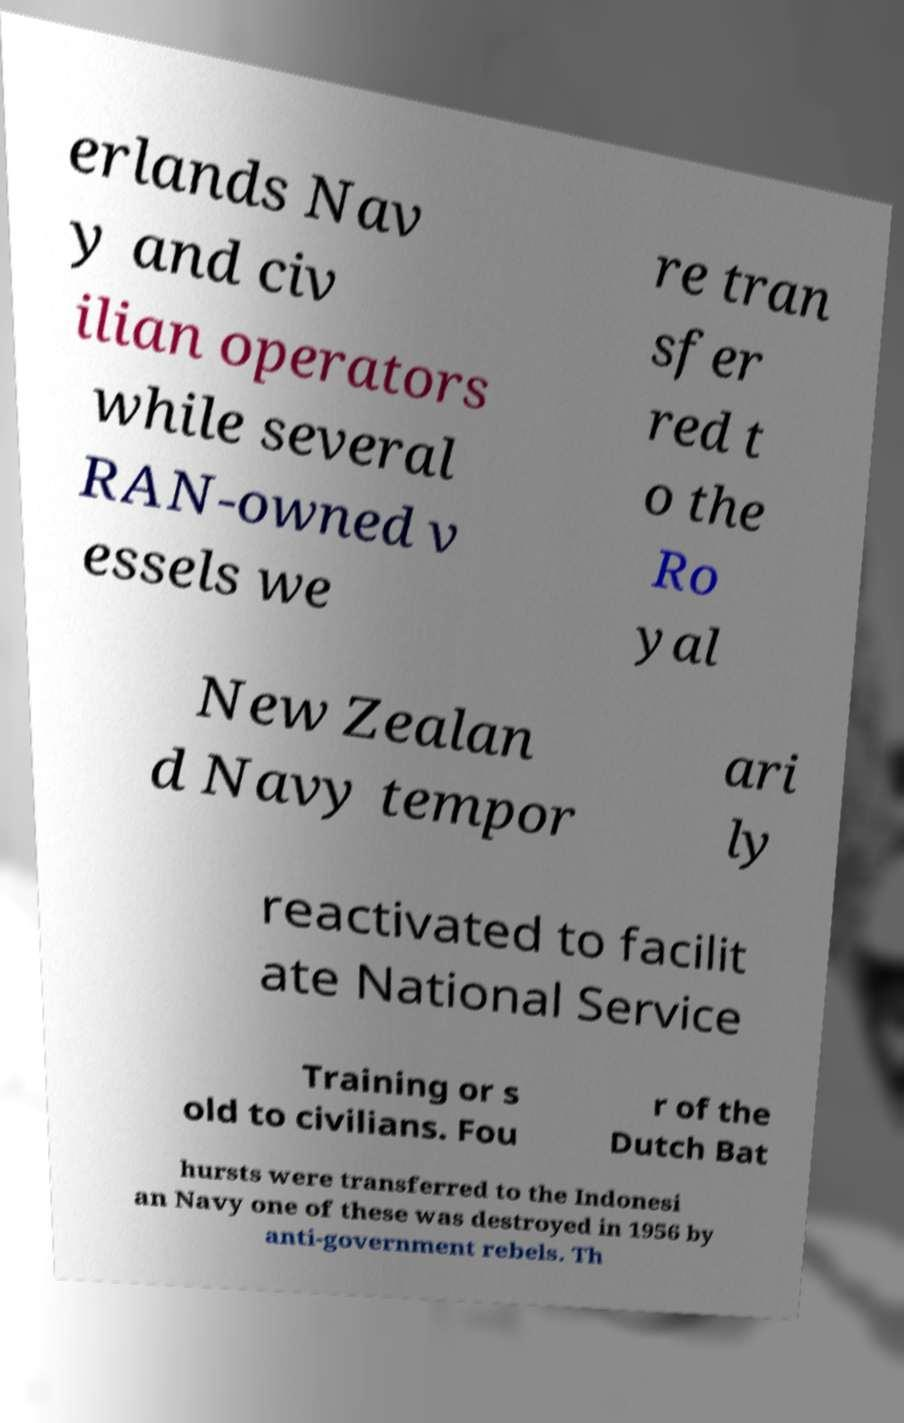There's text embedded in this image that I need extracted. Can you transcribe it verbatim? erlands Nav y and civ ilian operators while several RAN-owned v essels we re tran sfer red t o the Ro yal New Zealan d Navy tempor ari ly reactivated to facilit ate National Service Training or s old to civilians. Fou r of the Dutch Bat hursts were transferred to the Indonesi an Navy one of these was destroyed in 1956 by anti-government rebels. Th 